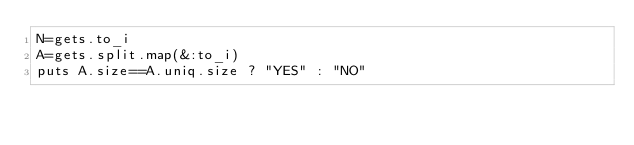Convert code to text. <code><loc_0><loc_0><loc_500><loc_500><_Ruby_>N=gets.to_i
A=gets.split.map(&:to_i)
puts A.size==A.uniq.size ? "YES" : "NO"</code> 